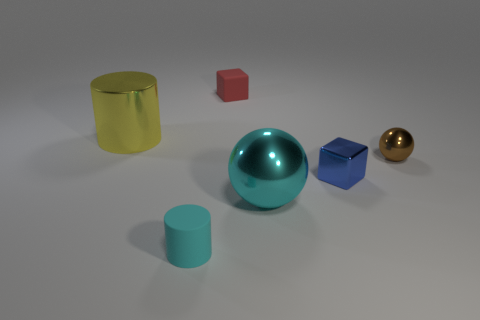There is a matte object that is to the left of the rubber object that is behind the big cylinder; what is its shape?
Offer a terse response. Cylinder. Is there any other thing that is the same color as the small rubber block?
Give a very brief answer. No. Does the tiny matte cube have the same color as the large metallic cylinder?
Make the answer very short. No. How many brown things are big shiny objects or small rubber cylinders?
Provide a short and direct response. 0. Are there fewer objects that are to the left of the red matte block than small purple rubber things?
Ensure brevity in your answer.  No. What number of tiny metal blocks are in front of the tiny rubber object that is in front of the blue shiny block?
Ensure brevity in your answer.  0. How many other objects are the same size as the metal cube?
Ensure brevity in your answer.  3. How many objects are small matte cubes or large things in front of the brown metal thing?
Keep it short and to the point. 2. Are there fewer tiny shiny spheres than large purple matte objects?
Provide a short and direct response. No. There is a small rubber thing behind the big shiny object that is in front of the yellow cylinder; what is its color?
Your response must be concise. Red. 